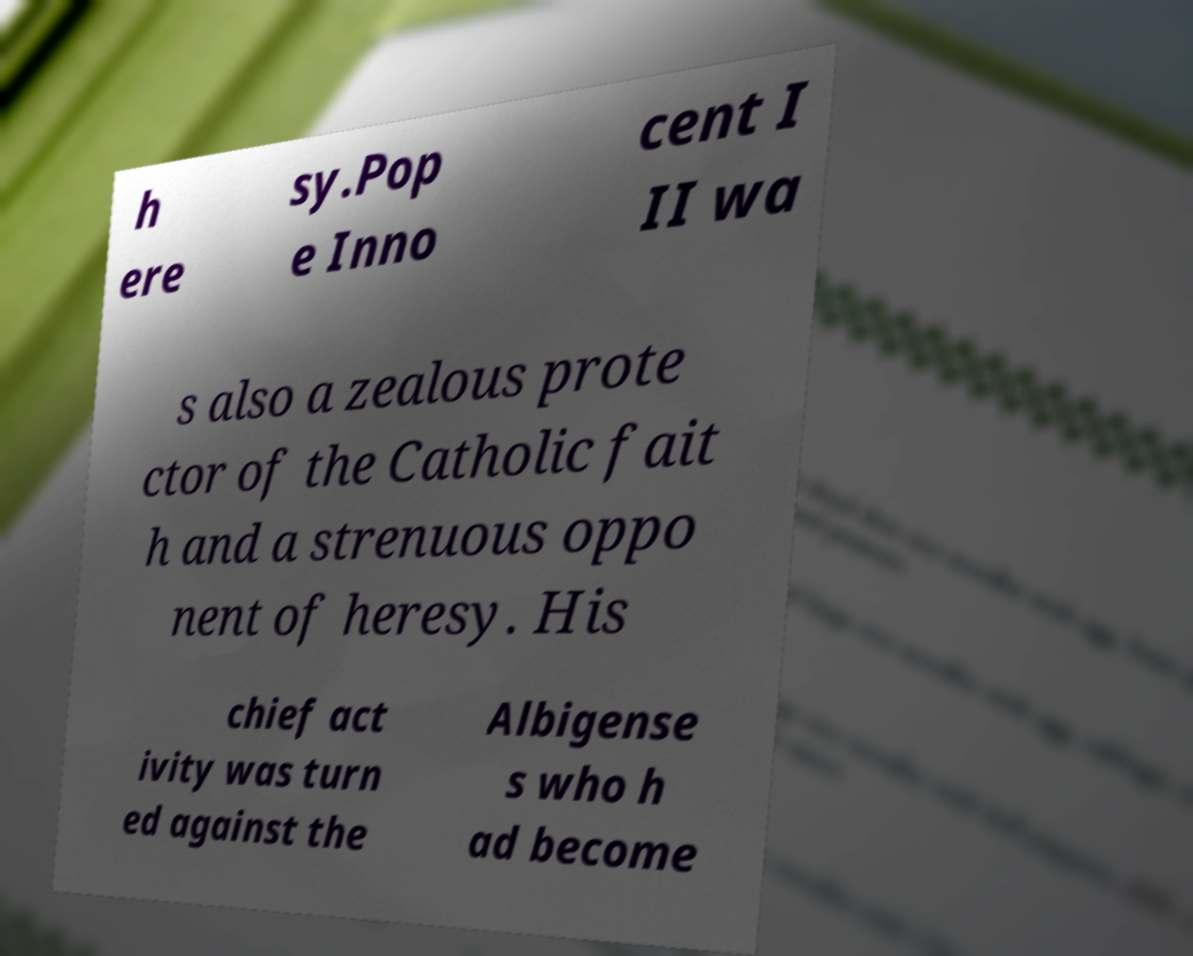What messages or text are displayed in this image? I need them in a readable, typed format. h ere sy.Pop e Inno cent I II wa s also a zealous prote ctor of the Catholic fait h and a strenuous oppo nent of heresy. His chief act ivity was turn ed against the Albigense s who h ad become 